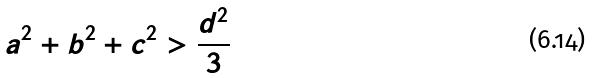Convert formula to latex. <formula><loc_0><loc_0><loc_500><loc_500>a ^ { 2 } + b ^ { 2 } + c ^ { 2 } > \frac { d ^ { 2 } } { 3 }</formula> 